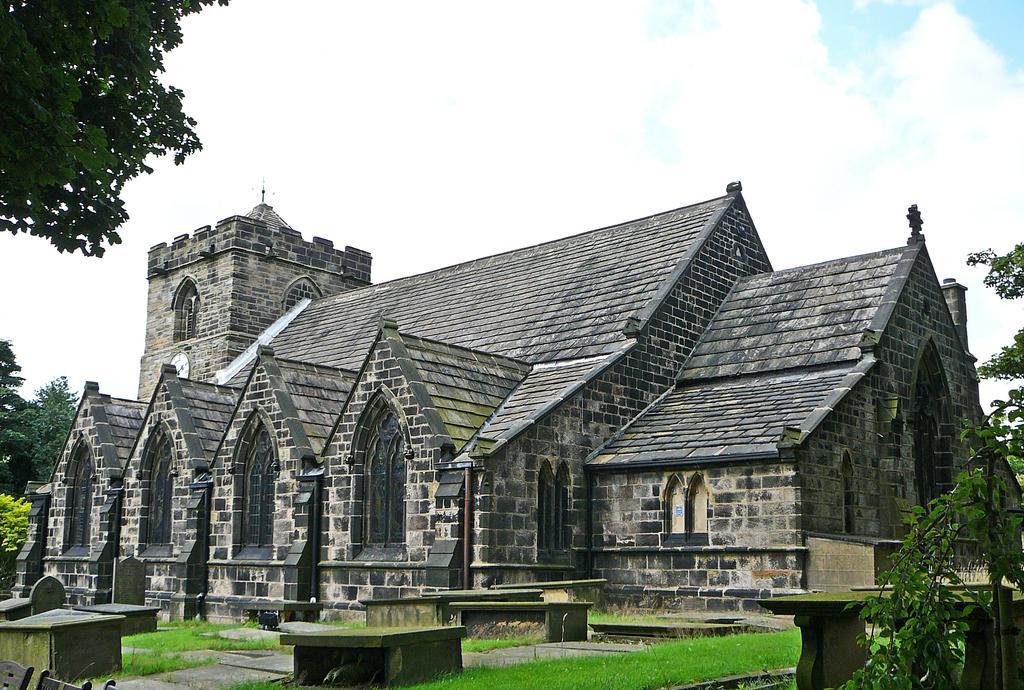Describe this image in one or two sentences. In this image I can see a building in grey and brown color. I can see windows,cement benches and trees. The sky is in blue and white color. 